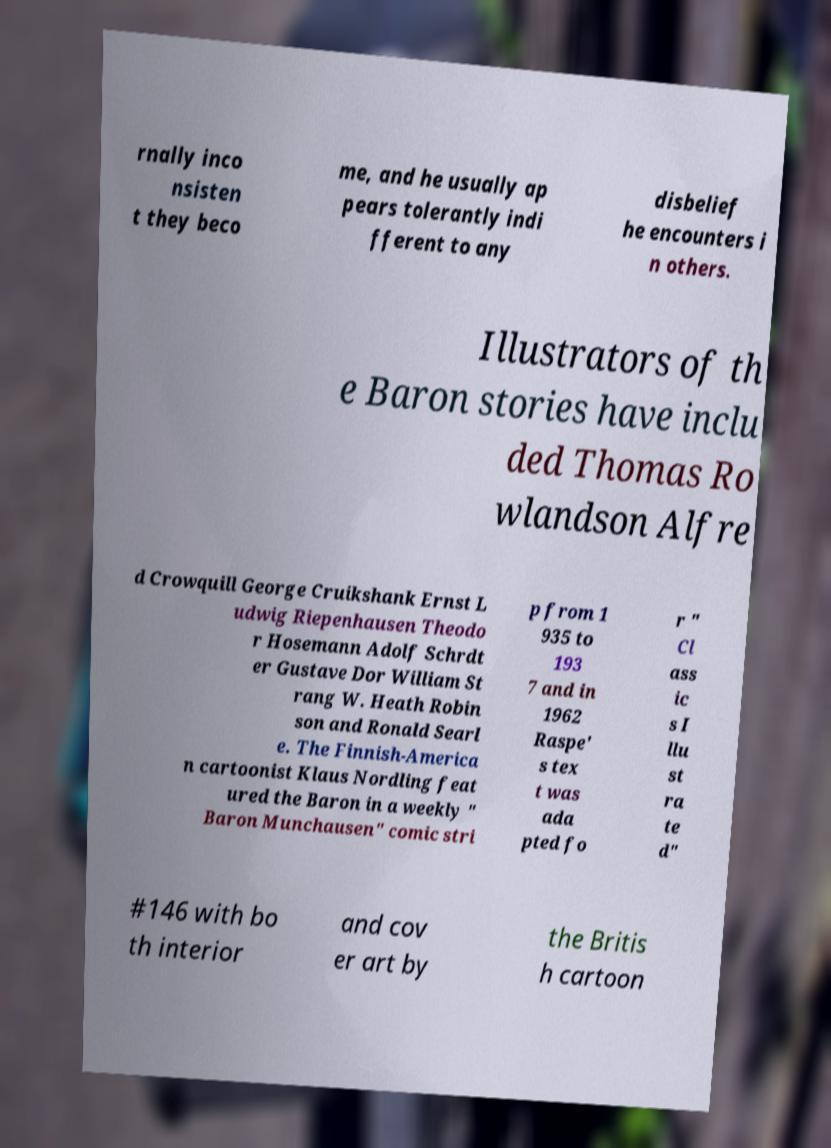I need the written content from this picture converted into text. Can you do that? rnally inco nsisten t they beco me, and he usually ap pears tolerantly indi fferent to any disbelief he encounters i n others. Illustrators of th e Baron stories have inclu ded Thomas Ro wlandson Alfre d Crowquill George Cruikshank Ernst L udwig Riepenhausen Theodo r Hosemann Adolf Schrdt er Gustave Dor William St rang W. Heath Robin son and Ronald Searl e. The Finnish-America n cartoonist Klaus Nordling feat ured the Baron in a weekly " Baron Munchausen" comic stri p from 1 935 to 193 7 and in 1962 Raspe' s tex t was ada pted fo r " Cl ass ic s I llu st ra te d" #146 with bo th interior and cov er art by the Britis h cartoon 